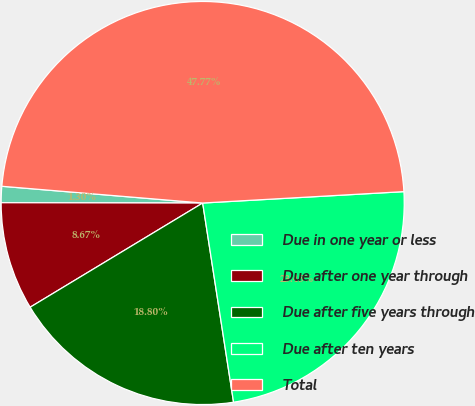Convert chart to OTSL. <chart><loc_0><loc_0><loc_500><loc_500><pie_chart><fcel>Due in one year or less<fcel>Due after one year through<fcel>Due after five years through<fcel>Due after ten years<fcel>Total<nl><fcel>1.3%<fcel>8.67%<fcel>18.8%<fcel>23.45%<fcel>47.77%<nl></chart> 